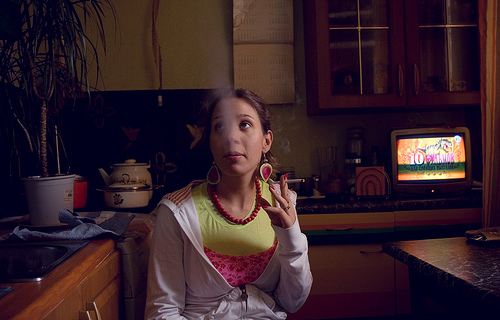Identify and read out the text in this image. 10 